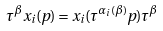Convert formula to latex. <formula><loc_0><loc_0><loc_500><loc_500>\tau ^ { \beta } x _ { i } ( p ) = x _ { i } ( \tau ^ { \alpha _ { i } ( \beta ) } p ) \tau ^ { \beta }</formula> 